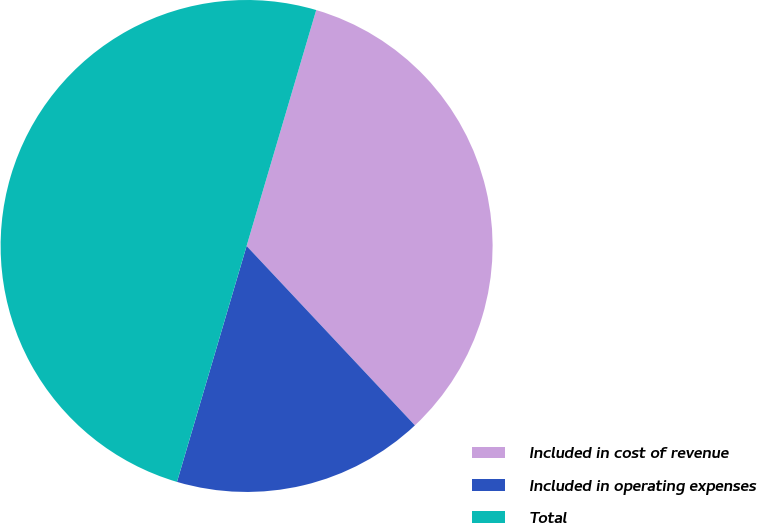<chart> <loc_0><loc_0><loc_500><loc_500><pie_chart><fcel>Included in cost of revenue<fcel>Included in operating expenses<fcel>Total<nl><fcel>33.44%<fcel>16.56%<fcel>50.0%<nl></chart> 